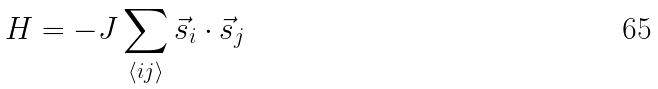Convert formula to latex. <formula><loc_0><loc_0><loc_500><loc_500>H = - J \sum _ { \langle i j \rangle } \vec { s } _ { i } \cdot \vec { s } _ { j }</formula> 